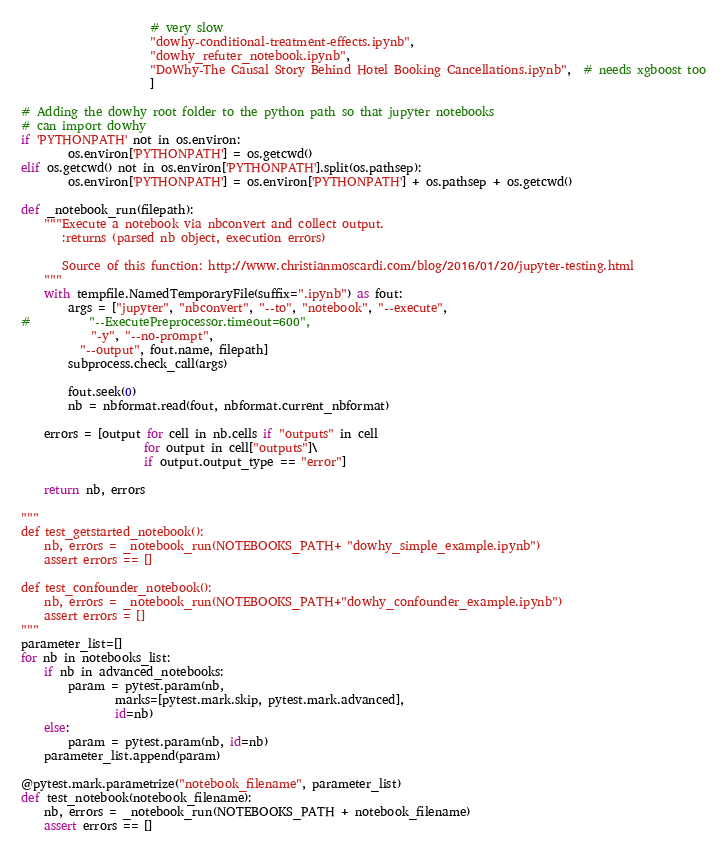<code> <loc_0><loc_0><loc_500><loc_500><_Python_>                      # very slow
                      "dowhy-conditional-treatment-effects.ipynb",
                      "dowhy_refuter_notebook.ipynb",
                      "DoWhy-The Causal Story Behind Hotel Booking Cancellations.ipynb",  # needs xgboost too
                      ]

# Adding the dowhy root folder to the python path so that jupyter notebooks
# can import dowhy
if 'PYTHONPATH' not in os.environ:
        os.environ['PYTHONPATH'] = os.getcwd()
elif os.getcwd() not in os.environ['PYTHONPATH'].split(os.pathsep):
        os.environ['PYTHONPATH'] = os.environ['PYTHONPATH'] + os.pathsep + os.getcwd()

def _notebook_run(filepath):
    """Execute a notebook via nbconvert and collect output.
       :returns (parsed nb object, execution errors)

       Source of this function: http://www.christianmoscardi.com/blog/2016/01/20/jupyter-testing.html
    """
    with tempfile.NamedTemporaryFile(suffix=".ipynb") as fout:
        args = ["jupyter", "nbconvert", "--to", "notebook", "--execute",
#          "--ExecutePreprocessor.timeout=600",
            "-y", "--no-prompt",
          "--output", fout.name, filepath]
        subprocess.check_call(args)

        fout.seek(0)
        nb = nbformat.read(fout, nbformat.current_nbformat)

    errors = [output for cell in nb.cells if "outputs" in cell
                     for output in cell["outputs"]\
                     if output.output_type == "error"]

    return nb, errors

"""
def test_getstarted_notebook():
    nb, errors = _notebook_run(NOTEBOOKS_PATH+ "dowhy_simple_example.ipynb")
    assert errors == []

def test_confounder_notebook():
    nb, errors = _notebook_run(NOTEBOOKS_PATH+"dowhy_confounder_example.ipynb")
    assert errors = []
"""
parameter_list=[]
for nb in notebooks_list:
    if nb in advanced_notebooks:
        param = pytest.param(nb,
                marks=[pytest.mark.skip, pytest.mark.advanced],
                id=nb)
    else:
        param = pytest.param(nb, id=nb)
    parameter_list.append(param)

@pytest.mark.parametrize("notebook_filename", parameter_list)
def test_notebook(notebook_filename):
    nb, errors = _notebook_run(NOTEBOOKS_PATH + notebook_filename)
    assert errors == []

</code> 